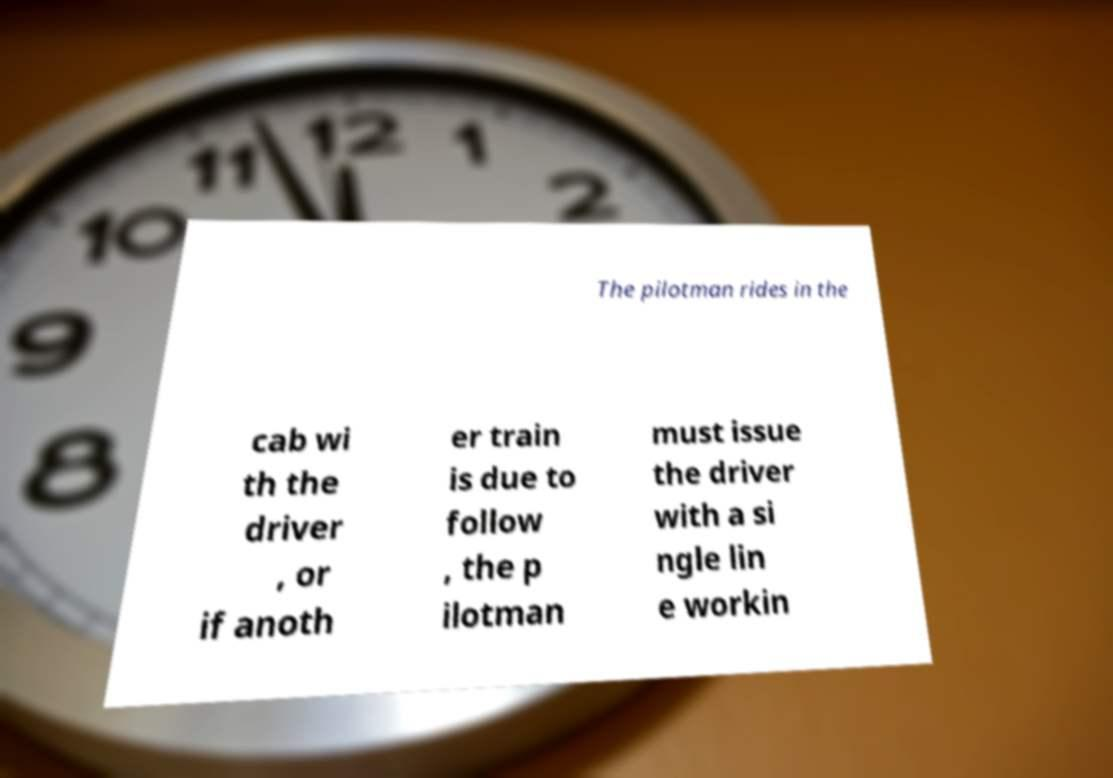What messages or text are displayed in this image? I need them in a readable, typed format. The pilotman rides in the cab wi th the driver , or if anoth er train is due to follow , the p ilotman must issue the driver with a si ngle lin e workin 